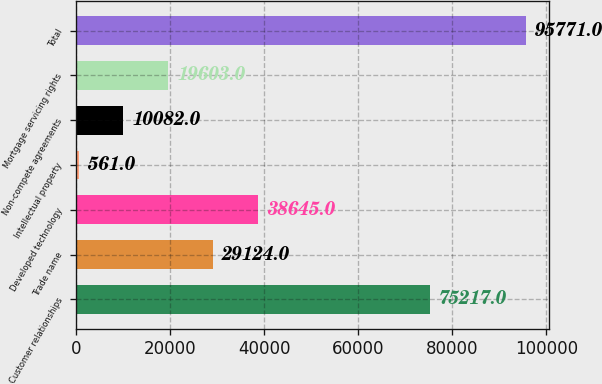Convert chart to OTSL. <chart><loc_0><loc_0><loc_500><loc_500><bar_chart><fcel>Customer relationships<fcel>Trade name<fcel>Developed technology<fcel>Intellectual property<fcel>Non-compete agreements<fcel>Mortgage servicing rights<fcel>Total<nl><fcel>75217<fcel>29124<fcel>38645<fcel>561<fcel>10082<fcel>19603<fcel>95771<nl></chart> 